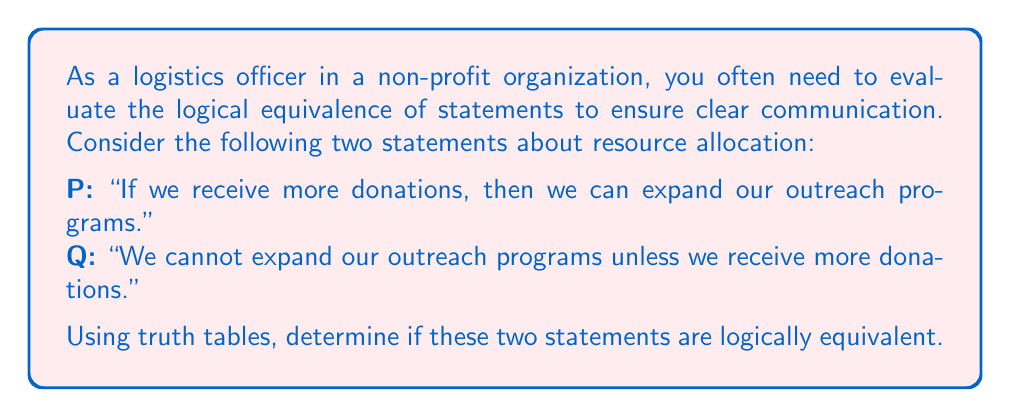Can you solve this math problem? To determine if the two statements are logically equivalent, we need to create truth tables for both statements and compare their results. Let's break this down step-by-step:

1. First, let's identify the logical structure of each statement:
   P: $p \rightarrow q$
   Q: $\neg q \rightarrow \neg p$ (contrapositive of $p \rightarrow q$)

   Where:
   $p$: "We receive more donations"
   $q$: "We can expand our outreach programs"

2. Now, let's create a truth table for both statements:

   $$\begin{array}{|c|c|c|c|c|c|}
   \hline
   p & q & p \rightarrow q & \neg q & \neg p & \neg q \rightarrow \neg p \\
   \hline
   T & T & T & F & F & T \\
   T & F & F & T & F & F \\
   F & T & T & F & T & T \\
   F & F & T & T & T & T \\
   \hline
   \end{array}$$

3. Let's evaluate each row:
   - When $p$ and $q$ are both true, both statements are true.
   - When $p$ is true and $q$ is false, both statements are false.
   - When $p$ is false and $q$ is true, both statements are true.
   - When both $p$ and $q$ are false, both statements are true.

4. Comparing the truth values in the $p \rightarrow q$ column with the $\neg q \rightarrow \neg p$ column, we can see that they are identical for all possible combinations of $p$ and $q$.

5. Since the truth tables for both statements produce the same results in all cases, we can conclude that the statements are logically equivalent.

This logical equivalence demonstrates that in the context of resource allocation and program expansion, the original statement and its contrapositive convey the same logical relationship between donations and outreach programs.
Answer: The two statements are logically equivalent, as demonstrated by their identical truth table results. 